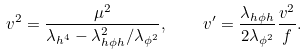<formula> <loc_0><loc_0><loc_500><loc_500>v ^ { 2 } = \frac { \mu ^ { 2 } } { \lambda _ { h ^ { 4 } } - \lambda _ { h \phi h } ^ { 2 } / \lambda _ { \phi ^ { 2 } } } , \quad v ^ { \prime } = \frac { \lambda _ { h \phi h } } { 2 \lambda _ { \phi ^ { 2 } } } \frac { v ^ { 2 } } { f } .</formula> 